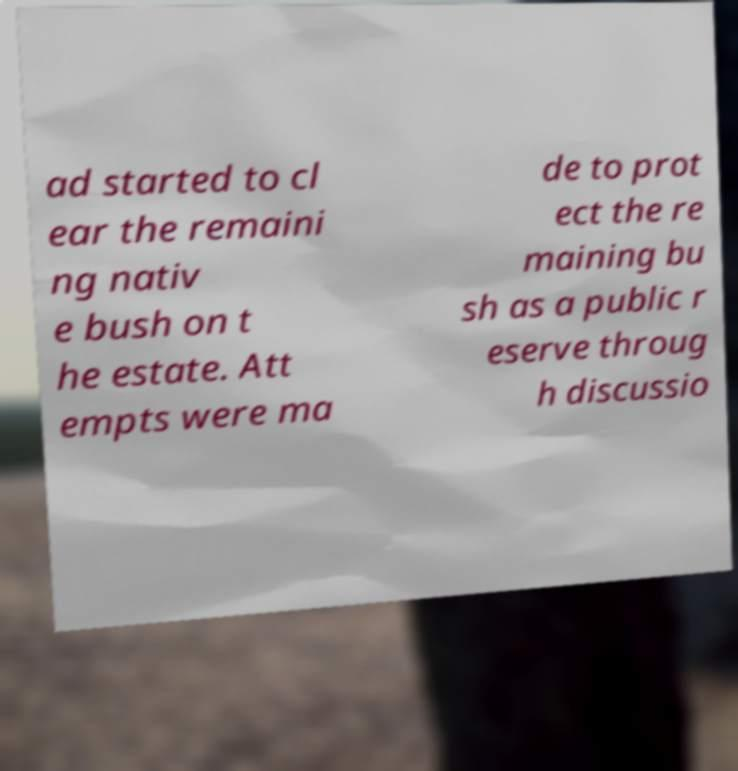There's text embedded in this image that I need extracted. Can you transcribe it verbatim? ad started to cl ear the remaini ng nativ e bush on t he estate. Att empts were ma de to prot ect the re maining bu sh as a public r eserve throug h discussio 